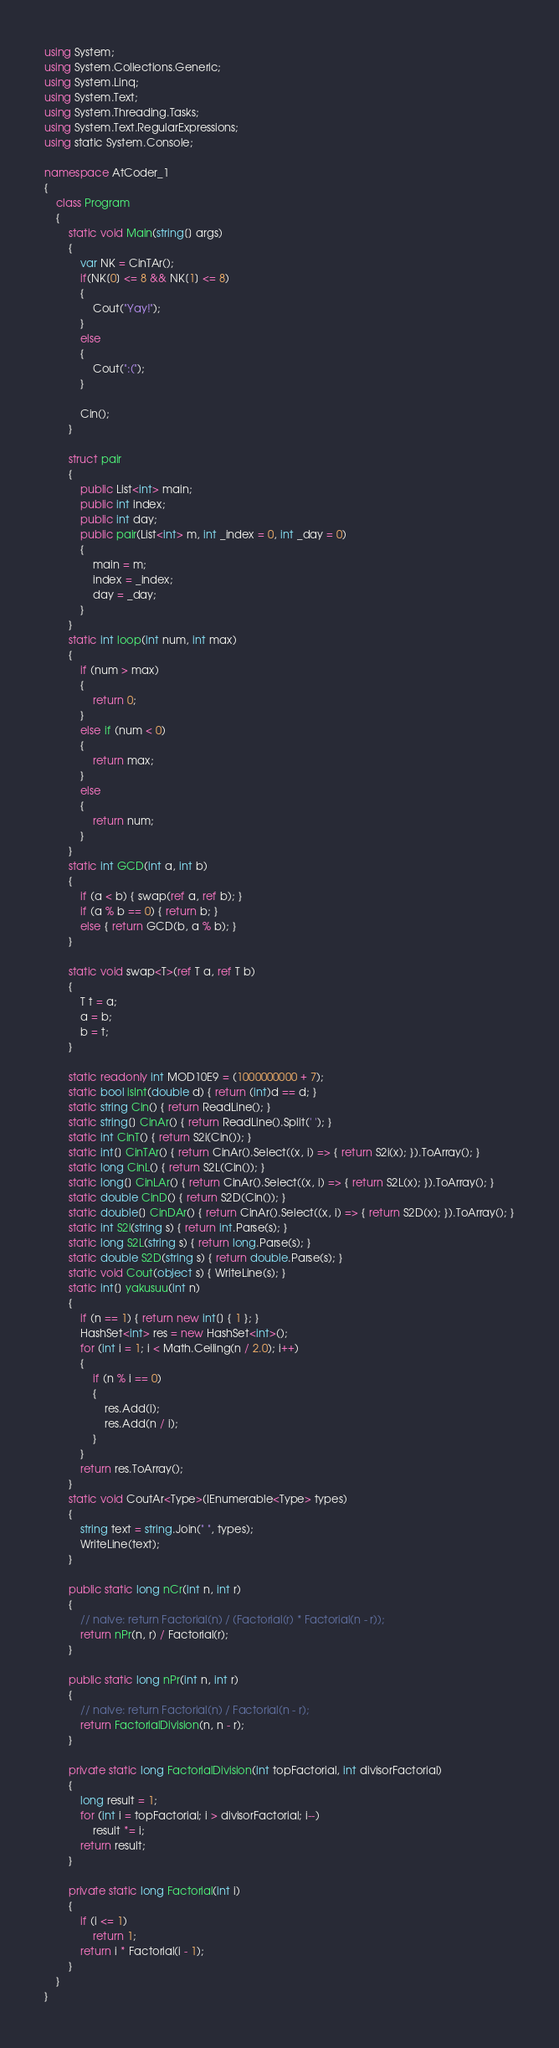Convert code to text. <code><loc_0><loc_0><loc_500><loc_500><_C#_>using System;
using System.Collections.Generic;
using System.Linq;
using System.Text;
using System.Threading.Tasks;
using System.Text.RegularExpressions;
using static System.Console;

namespace AtCoder_1
{
    class Program
    {
        static void Main(string[] args)
        {
            var NK = CinTAr();
            if(NK[0] <= 8 && NK[1] <= 8)
            {
                Cout("Yay!");
            }
            else
            {
                Cout(":(");
            }

            Cin();
        }

        struct pair
        {
            public List<int> main;
            public int index;
            public int day;
            public pair(List<int> m, int _index = 0, int _day = 0)
            {
                main = m;
                index = _index;
                day = _day;
            }
        }
        static int loop(int num, int max)
        {
            if (num > max)
            {
                return 0;
            }
            else if (num < 0)
            {
                return max;
            }
            else
            {
                return num;
            }
        }
        static int GCD(int a, int b)
        {
            if (a < b) { swap(ref a, ref b); }
            if (a % b == 0) { return b; }
            else { return GCD(b, a % b); }
        }

        static void swap<T>(ref T a, ref T b)
        {
            T t = a;
            a = b;
            b = t;
        }

        static readonly int MOD10E9 = (1000000000 + 7);
        static bool isInt(double d) { return (int)d == d; }
        static string Cin() { return ReadLine(); }
        static string[] CinAr() { return ReadLine().Split(' '); }
        static int CinT() { return S2i(Cin()); }
        static int[] CinTAr() { return CinAr().Select((x, i) => { return S2i(x); }).ToArray(); }
        static long CinL() { return S2L(Cin()); }
        static long[] CinLAr() { return CinAr().Select((x, i) => { return S2L(x); }).ToArray(); }
        static double CinD() { return S2D(Cin()); }
        static double[] CinDAr() { return CinAr().Select((x, i) => { return S2D(x); }).ToArray(); }
        static int S2i(string s) { return int.Parse(s); }
        static long S2L(string s) { return long.Parse(s); }
        static double S2D(string s) { return double.Parse(s); }
        static void Cout(object s) { WriteLine(s); }
        static int[] yakusuu(int n)
        {
            if (n == 1) { return new int[] { 1 }; }
            HashSet<int> res = new HashSet<int>();
            for (int i = 1; i < Math.Ceiling(n / 2.0); i++)
            {
                if (n % i == 0)
                {
                    res.Add(i);
                    res.Add(n / i);
                }
            }
            return res.ToArray();
        }
        static void CoutAr<Type>(IEnumerable<Type> types)
        {
            string text = string.Join(" ", types);
            WriteLine(text);
        }

        public static long nCr(int n, int r)
        {
            // naive: return Factorial(n) / (Factorial(r) * Factorial(n - r));
            return nPr(n, r) / Factorial(r);
        }

        public static long nPr(int n, int r)
        {
            // naive: return Factorial(n) / Factorial(n - r);
            return FactorialDivision(n, n - r);
        }

        private static long FactorialDivision(int topFactorial, int divisorFactorial)
        {
            long result = 1;
            for (int i = topFactorial; i > divisorFactorial; i--)
                result *= i;
            return result;
        }

        private static long Factorial(int i)
        {
            if (i <= 1)
                return 1;
            return i * Factorial(i - 1);
        }
    }
}
</code> 